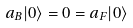Convert formula to latex. <formula><loc_0><loc_0><loc_500><loc_500>a _ { B } | 0 \rangle = 0 = a _ { F } | 0 \rangle</formula> 